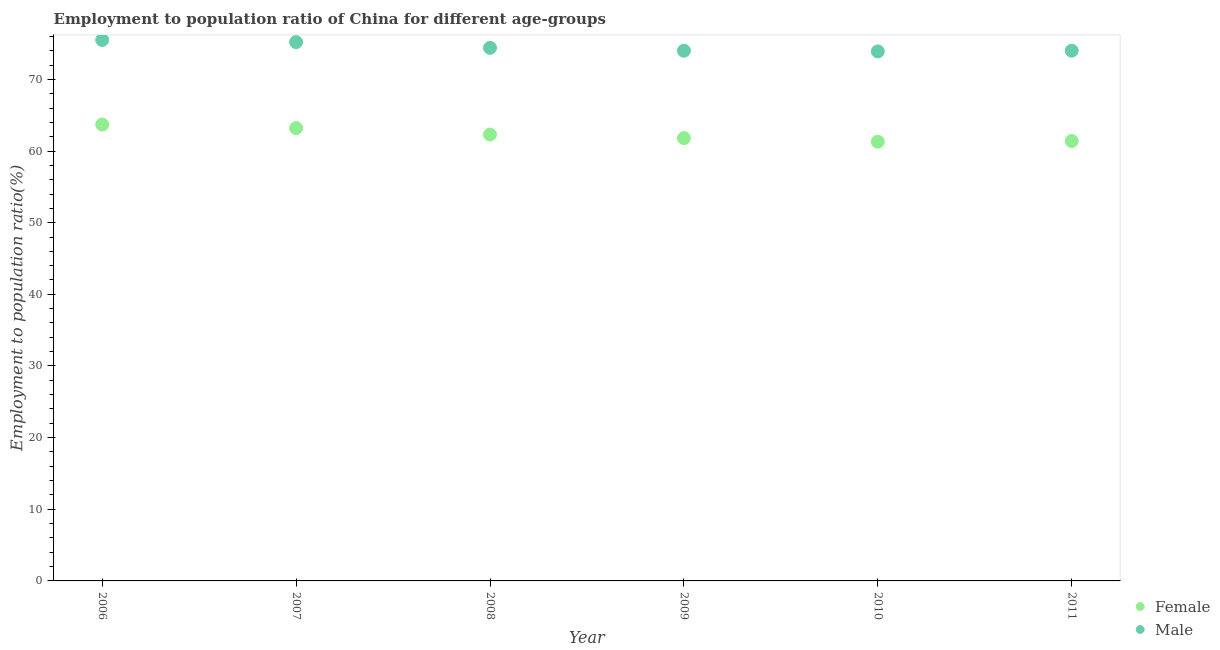Is the number of dotlines equal to the number of legend labels?
Offer a very short reply. Yes. What is the employment to population ratio(male) in 2008?
Ensure brevity in your answer.  74.4. Across all years, what is the maximum employment to population ratio(female)?
Ensure brevity in your answer.  63.7. Across all years, what is the minimum employment to population ratio(female)?
Give a very brief answer. 61.3. In which year was the employment to population ratio(female) maximum?
Keep it short and to the point. 2006. What is the total employment to population ratio(male) in the graph?
Your answer should be very brief. 447. What is the difference between the employment to population ratio(female) in 2009 and that in 2010?
Keep it short and to the point. 0.5. What is the difference between the employment to population ratio(female) in 2010 and the employment to population ratio(male) in 2008?
Provide a succinct answer. -13.1. What is the average employment to population ratio(female) per year?
Keep it short and to the point. 62.28. In the year 2011, what is the difference between the employment to population ratio(male) and employment to population ratio(female)?
Provide a short and direct response. 12.6. What is the ratio of the employment to population ratio(female) in 2006 to that in 2010?
Your response must be concise. 1.04. Is the employment to population ratio(female) in 2006 less than that in 2008?
Provide a succinct answer. No. Is the difference between the employment to population ratio(female) in 2006 and 2008 greater than the difference between the employment to population ratio(male) in 2006 and 2008?
Your response must be concise. Yes. What is the difference between the highest and the lowest employment to population ratio(male)?
Offer a terse response. 1.6. Is the sum of the employment to population ratio(male) in 2009 and 2011 greater than the maximum employment to population ratio(female) across all years?
Offer a very short reply. Yes. Is the employment to population ratio(male) strictly less than the employment to population ratio(female) over the years?
Your answer should be compact. No. What is the difference between two consecutive major ticks on the Y-axis?
Offer a terse response. 10. Does the graph contain any zero values?
Your answer should be compact. No. Does the graph contain grids?
Make the answer very short. No. Where does the legend appear in the graph?
Your response must be concise. Bottom right. What is the title of the graph?
Make the answer very short. Employment to population ratio of China for different age-groups. Does "Female labor force" appear as one of the legend labels in the graph?
Give a very brief answer. No. What is the label or title of the Y-axis?
Offer a terse response. Employment to population ratio(%). What is the Employment to population ratio(%) of Female in 2006?
Ensure brevity in your answer.  63.7. What is the Employment to population ratio(%) of Male in 2006?
Your response must be concise. 75.5. What is the Employment to population ratio(%) in Female in 2007?
Provide a succinct answer. 63.2. What is the Employment to population ratio(%) of Male in 2007?
Offer a very short reply. 75.2. What is the Employment to population ratio(%) of Female in 2008?
Your response must be concise. 62.3. What is the Employment to population ratio(%) of Male in 2008?
Offer a very short reply. 74.4. What is the Employment to population ratio(%) in Female in 2009?
Offer a terse response. 61.8. What is the Employment to population ratio(%) of Female in 2010?
Offer a terse response. 61.3. What is the Employment to population ratio(%) in Male in 2010?
Your response must be concise. 73.9. What is the Employment to population ratio(%) in Female in 2011?
Offer a very short reply. 61.4. What is the Employment to population ratio(%) of Male in 2011?
Your answer should be compact. 74. Across all years, what is the maximum Employment to population ratio(%) of Female?
Offer a terse response. 63.7. Across all years, what is the maximum Employment to population ratio(%) in Male?
Offer a terse response. 75.5. Across all years, what is the minimum Employment to population ratio(%) in Female?
Offer a very short reply. 61.3. Across all years, what is the minimum Employment to population ratio(%) in Male?
Ensure brevity in your answer.  73.9. What is the total Employment to population ratio(%) of Female in the graph?
Keep it short and to the point. 373.7. What is the total Employment to population ratio(%) of Male in the graph?
Provide a succinct answer. 447. What is the difference between the Employment to population ratio(%) of Male in 2006 and that in 2007?
Offer a terse response. 0.3. What is the difference between the Employment to population ratio(%) in Male in 2006 and that in 2008?
Offer a terse response. 1.1. What is the difference between the Employment to population ratio(%) of Female in 2006 and that in 2010?
Give a very brief answer. 2.4. What is the difference between the Employment to population ratio(%) of Male in 2006 and that in 2010?
Offer a terse response. 1.6. What is the difference between the Employment to population ratio(%) of Female in 2007 and that in 2008?
Give a very brief answer. 0.9. What is the difference between the Employment to population ratio(%) of Male in 2007 and that in 2009?
Your answer should be compact. 1.2. What is the difference between the Employment to population ratio(%) in Male in 2007 and that in 2010?
Your response must be concise. 1.3. What is the difference between the Employment to population ratio(%) in Female in 2008 and that in 2010?
Offer a terse response. 1. What is the difference between the Employment to population ratio(%) in Male in 2008 and that in 2010?
Keep it short and to the point. 0.5. What is the difference between the Employment to population ratio(%) of Female in 2008 and that in 2011?
Ensure brevity in your answer.  0.9. What is the difference between the Employment to population ratio(%) in Male in 2008 and that in 2011?
Your answer should be compact. 0.4. What is the difference between the Employment to population ratio(%) in Female in 2009 and that in 2010?
Provide a short and direct response. 0.5. What is the difference between the Employment to population ratio(%) of Female in 2006 and the Employment to population ratio(%) of Male in 2007?
Make the answer very short. -11.5. What is the difference between the Employment to population ratio(%) of Female in 2006 and the Employment to population ratio(%) of Male in 2008?
Ensure brevity in your answer.  -10.7. What is the difference between the Employment to population ratio(%) of Female in 2006 and the Employment to population ratio(%) of Male in 2009?
Ensure brevity in your answer.  -10.3. What is the difference between the Employment to population ratio(%) in Female in 2006 and the Employment to population ratio(%) in Male in 2011?
Offer a terse response. -10.3. What is the difference between the Employment to population ratio(%) of Female in 2008 and the Employment to population ratio(%) of Male in 2009?
Your answer should be compact. -11.7. What is the difference between the Employment to population ratio(%) of Female in 2008 and the Employment to population ratio(%) of Male in 2010?
Give a very brief answer. -11.6. What is the difference between the Employment to population ratio(%) of Female in 2008 and the Employment to population ratio(%) of Male in 2011?
Your response must be concise. -11.7. What is the average Employment to population ratio(%) in Female per year?
Make the answer very short. 62.28. What is the average Employment to population ratio(%) of Male per year?
Provide a short and direct response. 74.5. In the year 2008, what is the difference between the Employment to population ratio(%) of Female and Employment to population ratio(%) of Male?
Offer a terse response. -12.1. What is the ratio of the Employment to population ratio(%) in Female in 2006 to that in 2007?
Offer a very short reply. 1.01. What is the ratio of the Employment to population ratio(%) of Male in 2006 to that in 2007?
Keep it short and to the point. 1. What is the ratio of the Employment to population ratio(%) in Female in 2006 to that in 2008?
Ensure brevity in your answer.  1.02. What is the ratio of the Employment to population ratio(%) of Male in 2006 to that in 2008?
Make the answer very short. 1.01. What is the ratio of the Employment to population ratio(%) of Female in 2006 to that in 2009?
Provide a succinct answer. 1.03. What is the ratio of the Employment to population ratio(%) in Male in 2006 to that in 2009?
Your answer should be very brief. 1.02. What is the ratio of the Employment to population ratio(%) of Female in 2006 to that in 2010?
Provide a succinct answer. 1.04. What is the ratio of the Employment to population ratio(%) of Male in 2006 to that in 2010?
Your response must be concise. 1.02. What is the ratio of the Employment to population ratio(%) of Female in 2006 to that in 2011?
Your response must be concise. 1.04. What is the ratio of the Employment to population ratio(%) in Male in 2006 to that in 2011?
Your answer should be compact. 1.02. What is the ratio of the Employment to population ratio(%) of Female in 2007 to that in 2008?
Offer a terse response. 1.01. What is the ratio of the Employment to population ratio(%) in Male in 2007 to that in 2008?
Provide a succinct answer. 1.01. What is the ratio of the Employment to population ratio(%) in Female in 2007 to that in 2009?
Provide a short and direct response. 1.02. What is the ratio of the Employment to population ratio(%) of Male in 2007 to that in 2009?
Provide a succinct answer. 1.02. What is the ratio of the Employment to population ratio(%) of Female in 2007 to that in 2010?
Keep it short and to the point. 1.03. What is the ratio of the Employment to population ratio(%) in Male in 2007 to that in 2010?
Your answer should be compact. 1.02. What is the ratio of the Employment to population ratio(%) in Female in 2007 to that in 2011?
Provide a short and direct response. 1.03. What is the ratio of the Employment to population ratio(%) of Male in 2007 to that in 2011?
Make the answer very short. 1.02. What is the ratio of the Employment to population ratio(%) of Male in 2008 to that in 2009?
Give a very brief answer. 1.01. What is the ratio of the Employment to population ratio(%) of Female in 2008 to that in 2010?
Make the answer very short. 1.02. What is the ratio of the Employment to population ratio(%) in Male in 2008 to that in 2010?
Offer a very short reply. 1.01. What is the ratio of the Employment to population ratio(%) of Female in 2008 to that in 2011?
Provide a short and direct response. 1.01. What is the ratio of the Employment to population ratio(%) in Male in 2008 to that in 2011?
Your response must be concise. 1.01. What is the ratio of the Employment to population ratio(%) of Female in 2009 to that in 2010?
Your answer should be very brief. 1.01. What is the ratio of the Employment to population ratio(%) of Male in 2009 to that in 2011?
Provide a succinct answer. 1. What is the difference between the highest and the second highest Employment to population ratio(%) in Male?
Offer a very short reply. 0.3. 